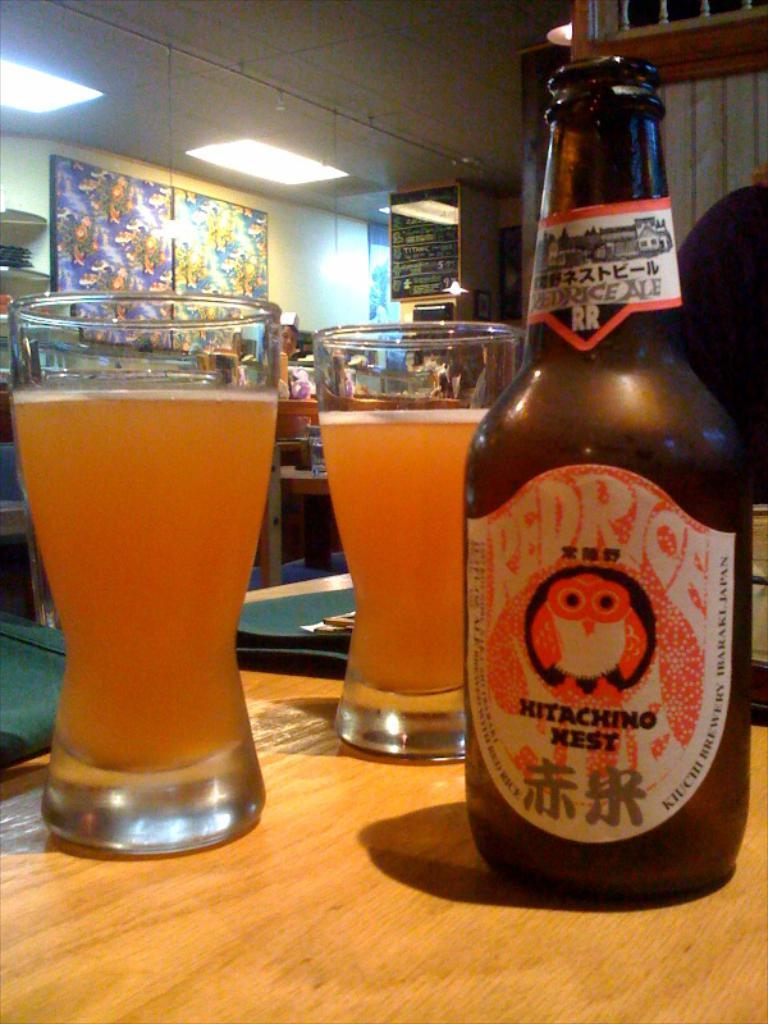<image>
Summarize the visual content of the image. A bottle with an owl on the label says Hitachin Nest. 